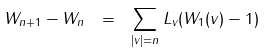Convert formula to latex. <formula><loc_0><loc_0><loc_500><loc_500>W _ { n + 1 } - W _ { n } \ = \ \sum _ { | v | = n } L _ { v } ( W _ { 1 } ( v ) - 1 )</formula> 